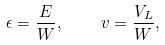<formula> <loc_0><loc_0><loc_500><loc_500>\epsilon = \frac { E } { W } , \quad v = \frac { V _ { L } } { W } ,</formula> 